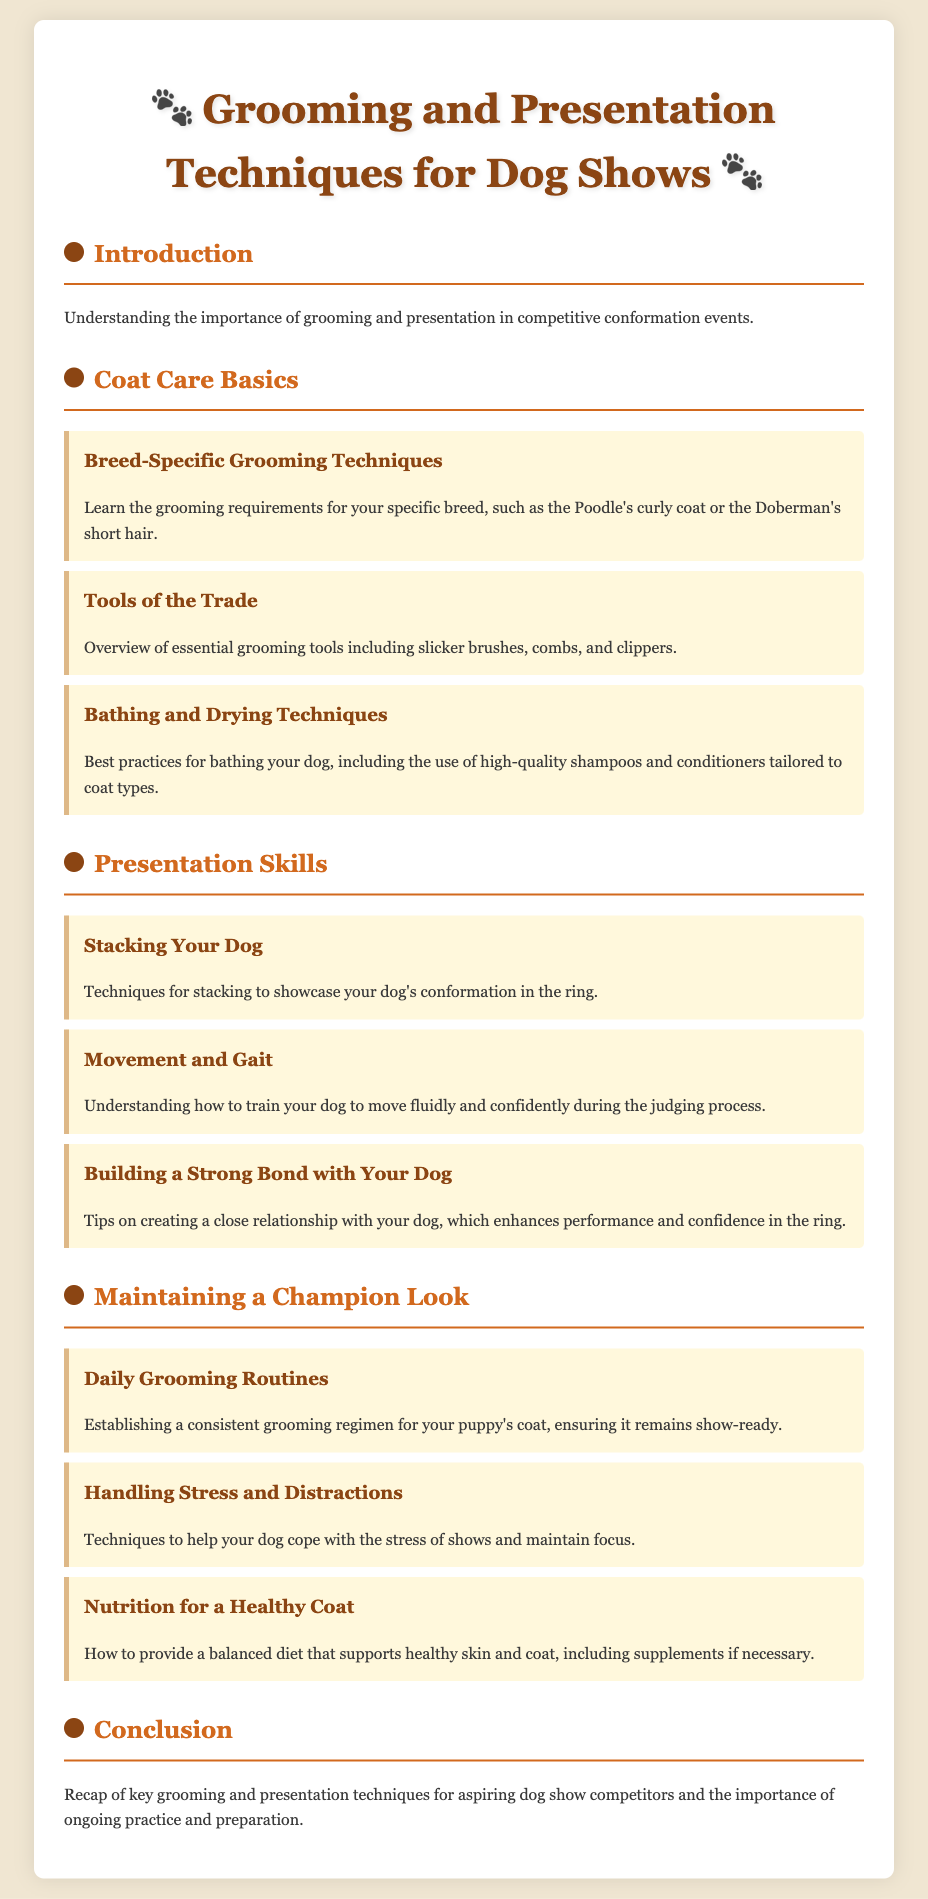what is the main topic of the document? The main topic of the document is about grooming and presentation techniques for dog shows.
Answer: grooming and presentation techniques for dog shows how many sections are there in the document? The document is structured into five main sections including Introduction, Coat Care Basics, Presentation Skills, Maintaining a Champion Look, and Conclusion.
Answer: five what does "daily grooming routines" focus on? "Daily grooming routines" focuses on establishing a consistent grooming regimen for your puppy's coat.
Answer: consistent grooming regimen which breed requires specific grooming techniques? The document states that specific grooming techniques are required for certain breeds such as the Poodle.
Answer: Poodle what is highlighted in the chapter on "movement and gait"? The chapter on "movement and gait" emphasizes how to train your dog to move fluidly and confidently.
Answer: training for fluid movement what are essential tools mentioned for grooming? The document lists essential grooming tools, including slicker brushes, combs, and clippers.
Answer: slicker brushes, combs, clippers how can owners help their dogs cope with show stress? The section on stress management discusses techniques to help dogs cope with the stress of shows.
Answer: techniques to manage stress what nutritional aspect is addressed for maintaining a healthy coat? The document addresses the importance of providing a balanced diet that supports healthy skin and coat.
Answer: balanced diet what should a grooming regimen ensure about the puppy's coat? A grooming regimen should ensure that the puppy's coat remains show-ready.
Answer: remain show-ready 